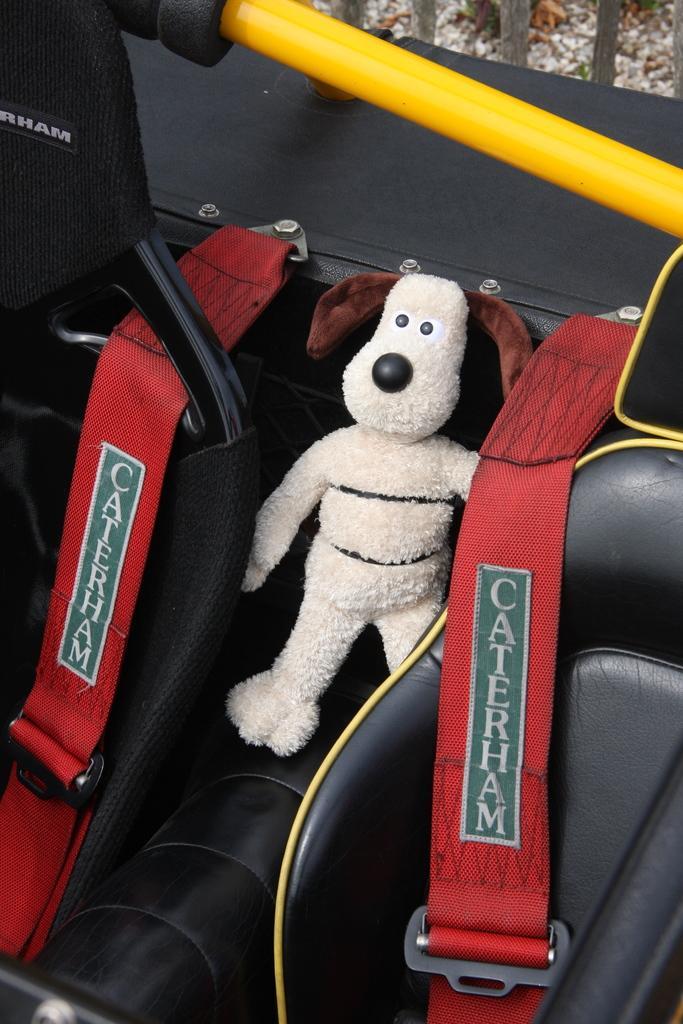Please provide a concise description of this image. In this picture I can see couple of chairs and a soft toy and I can see seat belts and I can see text on the seat belts. 